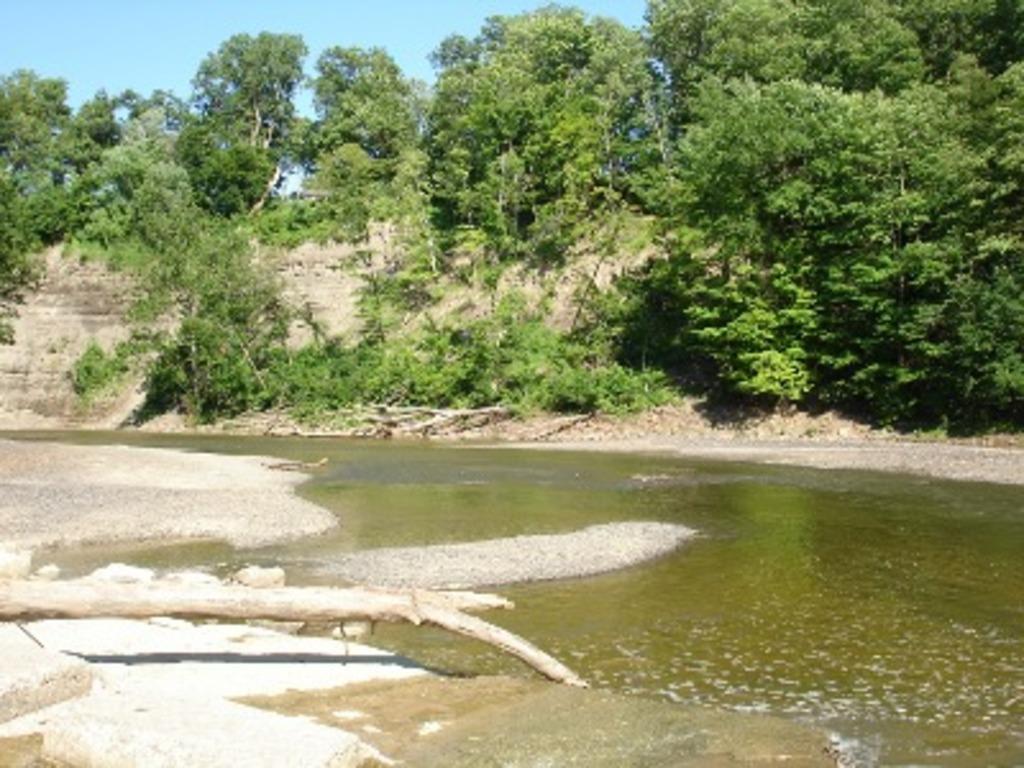Describe this image in one or two sentences. In this image on the foreground there is water body. Here is a wood log. In the background there are trees. The sky is clear. 